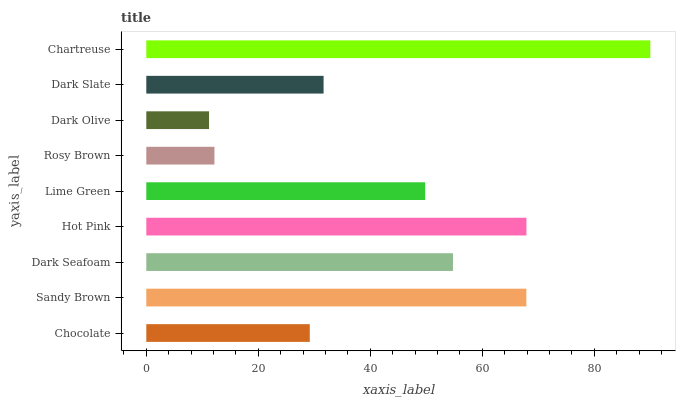Is Dark Olive the minimum?
Answer yes or no. Yes. Is Chartreuse the maximum?
Answer yes or no. Yes. Is Sandy Brown the minimum?
Answer yes or no. No. Is Sandy Brown the maximum?
Answer yes or no. No. Is Sandy Brown greater than Chocolate?
Answer yes or no. Yes. Is Chocolate less than Sandy Brown?
Answer yes or no. Yes. Is Chocolate greater than Sandy Brown?
Answer yes or no. No. Is Sandy Brown less than Chocolate?
Answer yes or no. No. Is Lime Green the high median?
Answer yes or no. Yes. Is Lime Green the low median?
Answer yes or no. Yes. Is Chartreuse the high median?
Answer yes or no. No. Is Hot Pink the low median?
Answer yes or no. No. 